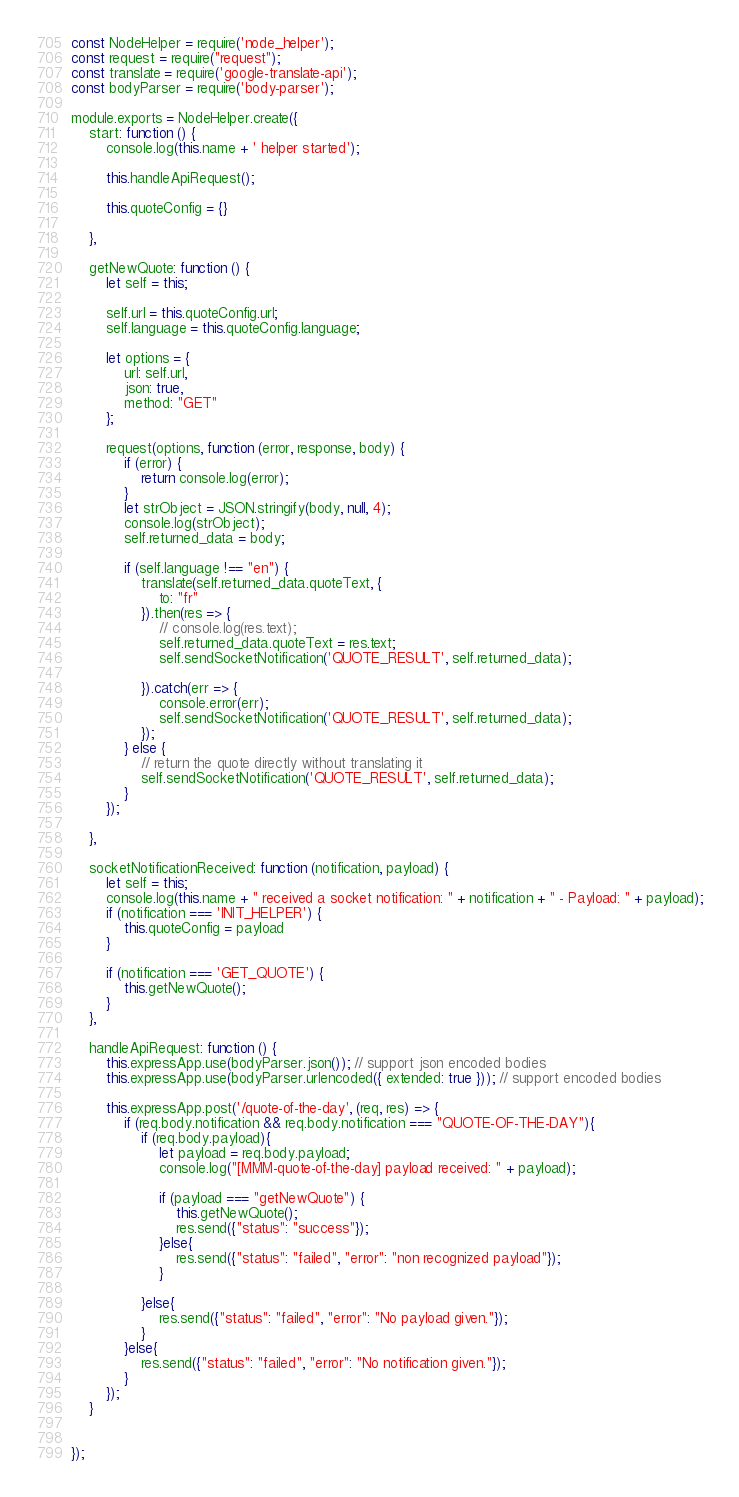Convert code to text. <code><loc_0><loc_0><loc_500><loc_500><_JavaScript_>const NodeHelper = require('node_helper');
const request = require("request");
const translate = require('google-translate-api');
const bodyParser = require('body-parser');

module.exports = NodeHelper.create({
    start: function () {
        console.log(this.name + ' helper started');

        this.handleApiRequest();

        this.quoteConfig = {}

    },

    getNewQuote: function () {
        let self = this;

        self.url = this.quoteConfig.url;
        self.language = this.quoteConfig.language;

        let options = {
            url: self.url,
            json: true,
            method: "GET"
        };

        request(options, function (error, response, body) {
            if (error) {
                return console.log(error);
            }
            let strObject = JSON.stringify(body, null, 4);
            console.log(strObject);
            self.returned_data = body;

            if (self.language !== "en") {
                translate(self.returned_data.quoteText, {
                    to: "fr"
                }).then(res => {
                    // console.log(res.text);
                    self.returned_data.quoteText = res.text;
                    self.sendSocketNotification('QUOTE_RESULT', self.returned_data);

                }).catch(err => {
                    console.error(err);
                    self.sendSocketNotification('QUOTE_RESULT', self.returned_data);
                });
            } else {
                // return the quote directly without translating it
                self.sendSocketNotification('QUOTE_RESULT', self.returned_data);
            }
        });

    },

    socketNotificationReceived: function (notification, payload) {
        let self = this;
        console.log(this.name + " received a socket notification: " + notification + " - Payload: " + payload);
        if (notification === 'INIT_HELPER') {
            this.quoteConfig = payload
        }

        if (notification === 'GET_QUOTE') {
            this.getNewQuote();
        }
    },

    handleApiRequest: function () {
        this.expressApp.use(bodyParser.json()); // support json encoded bodies
        this.expressApp.use(bodyParser.urlencoded({ extended: true })); // support encoded bodies

        this.expressApp.post('/quote-of-the-day', (req, res) => {
            if (req.body.notification && req.body.notification === "QUOTE-OF-THE-DAY"){
                if (req.body.payload){
                    let payload = req.body.payload;
                    console.log("[MMM-quote-of-the-day] payload received: " + payload);

                    if (payload === "getNewQuote") {
                        this.getNewQuote();
                        res.send({"status": "success"});
                    }else{
                        res.send({"status": "failed", "error": "non recognized payload"});
                    }

                }else{
                    res.send({"status": "failed", "error": "No payload given."});
                }
            }else{
                res.send({"status": "failed", "error": "No notification given."});
            }
        });
    }


});</code> 